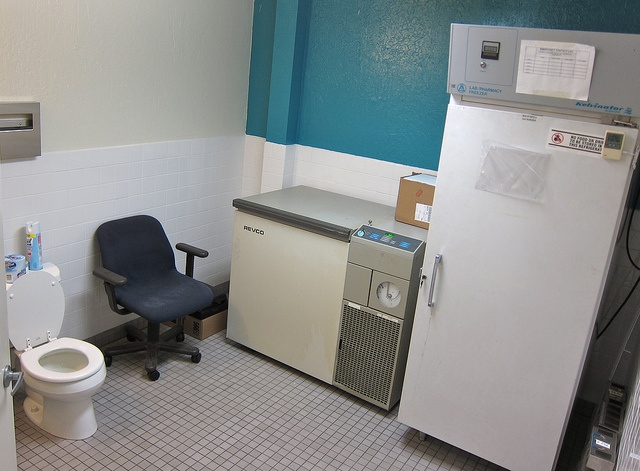Describe the objects in this image and their specific colors. I can see refrigerator in lightgray, darkgray, black, and gray tones, toilet in lightgray, darkgray, and gray tones, and chair in lightgray, black, and gray tones in this image. 